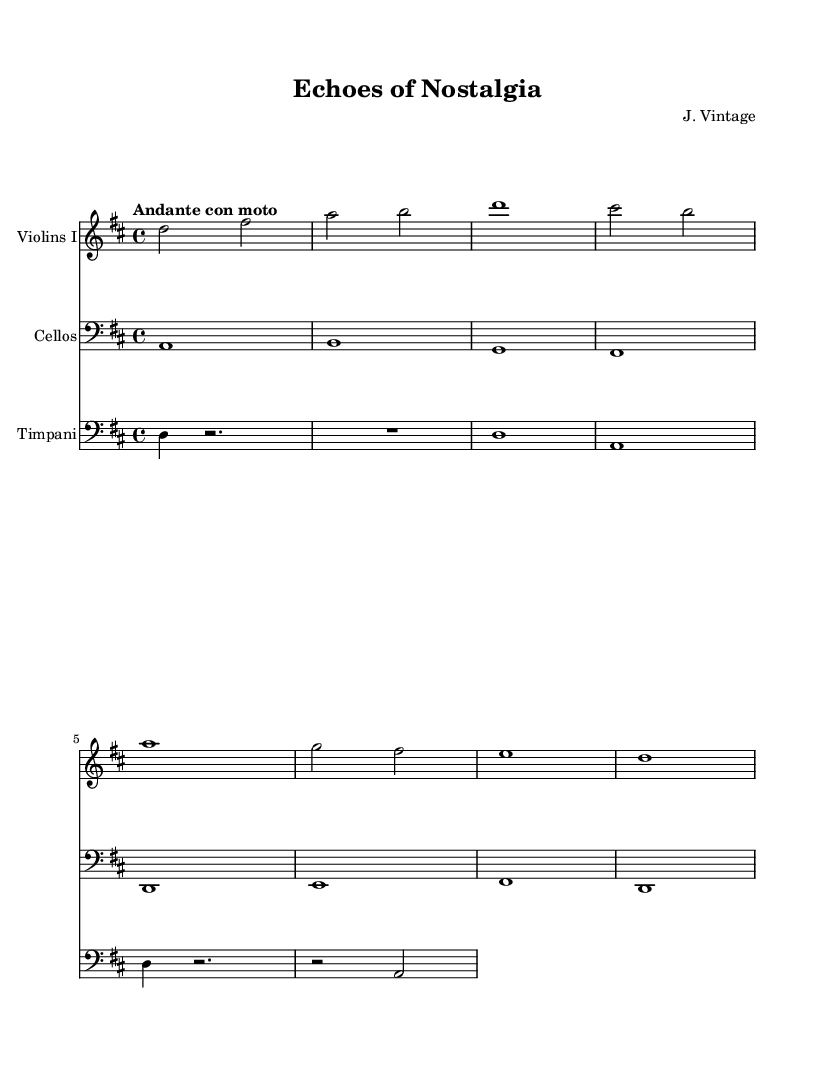What is the key signature of this music? The key signature is D major, which has two sharps (F# and C#).
Answer: D major What is the time signature of this music? The time signature is 4/4, indicating four beats per measure with a quarter note receiving one beat.
Answer: 4/4 What is the tempo marking of this music? The tempo marking is "Andante con moto", which means a moderately slow tempo with some movement.
Answer: Andante con moto How many measures are there in the Violins I part? By counting the individual bar lines in the Violins I part, we find a total of 8 measures.
Answer: 8 What is the rhythmic value of the first note in the Timpani part? The first note in the Timpani part is a quarter note, as indicated by the note head and its duration.
Answer: Quarter note What is the range of the cellos starting from their lowest note? The lowest note is an A1 and the range extends up to B1. This makes the range one octave.
Answer: One octave Which instruments have the same rhythmic pattern in the first measure? Both the Violins I and Timpani parts have similar rhythmic patterns where the Timpani has a quarter note and rest followed by note.
Answer: Violins I and Timpani 